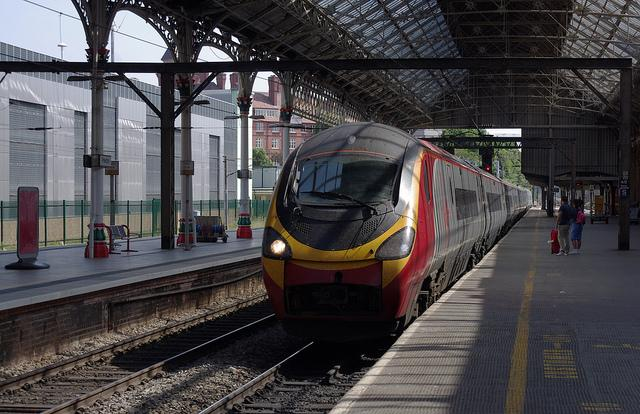Why are the people standing behind the yellow line?

Choices:
A) fun
B) safety
C) work
D) punishment safety 